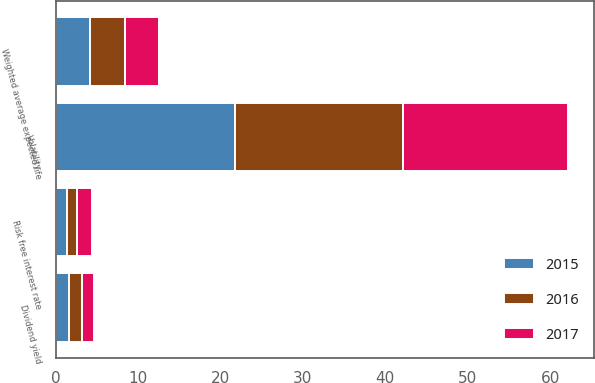Convert chart to OTSL. <chart><loc_0><loc_0><loc_500><loc_500><stacked_bar_chart><ecel><fcel>Risk free interest rate<fcel>Volatility<fcel>Dividend yield<fcel>Weighted average expected life<nl><fcel>2017<fcel>1.8<fcel>20.1<fcel>1.4<fcel>4.2<nl><fcel>2016<fcel>1.2<fcel>20.4<fcel>1.6<fcel>4.2<nl><fcel>2015<fcel>1.4<fcel>21.7<fcel>1.6<fcel>4.2<nl></chart> 